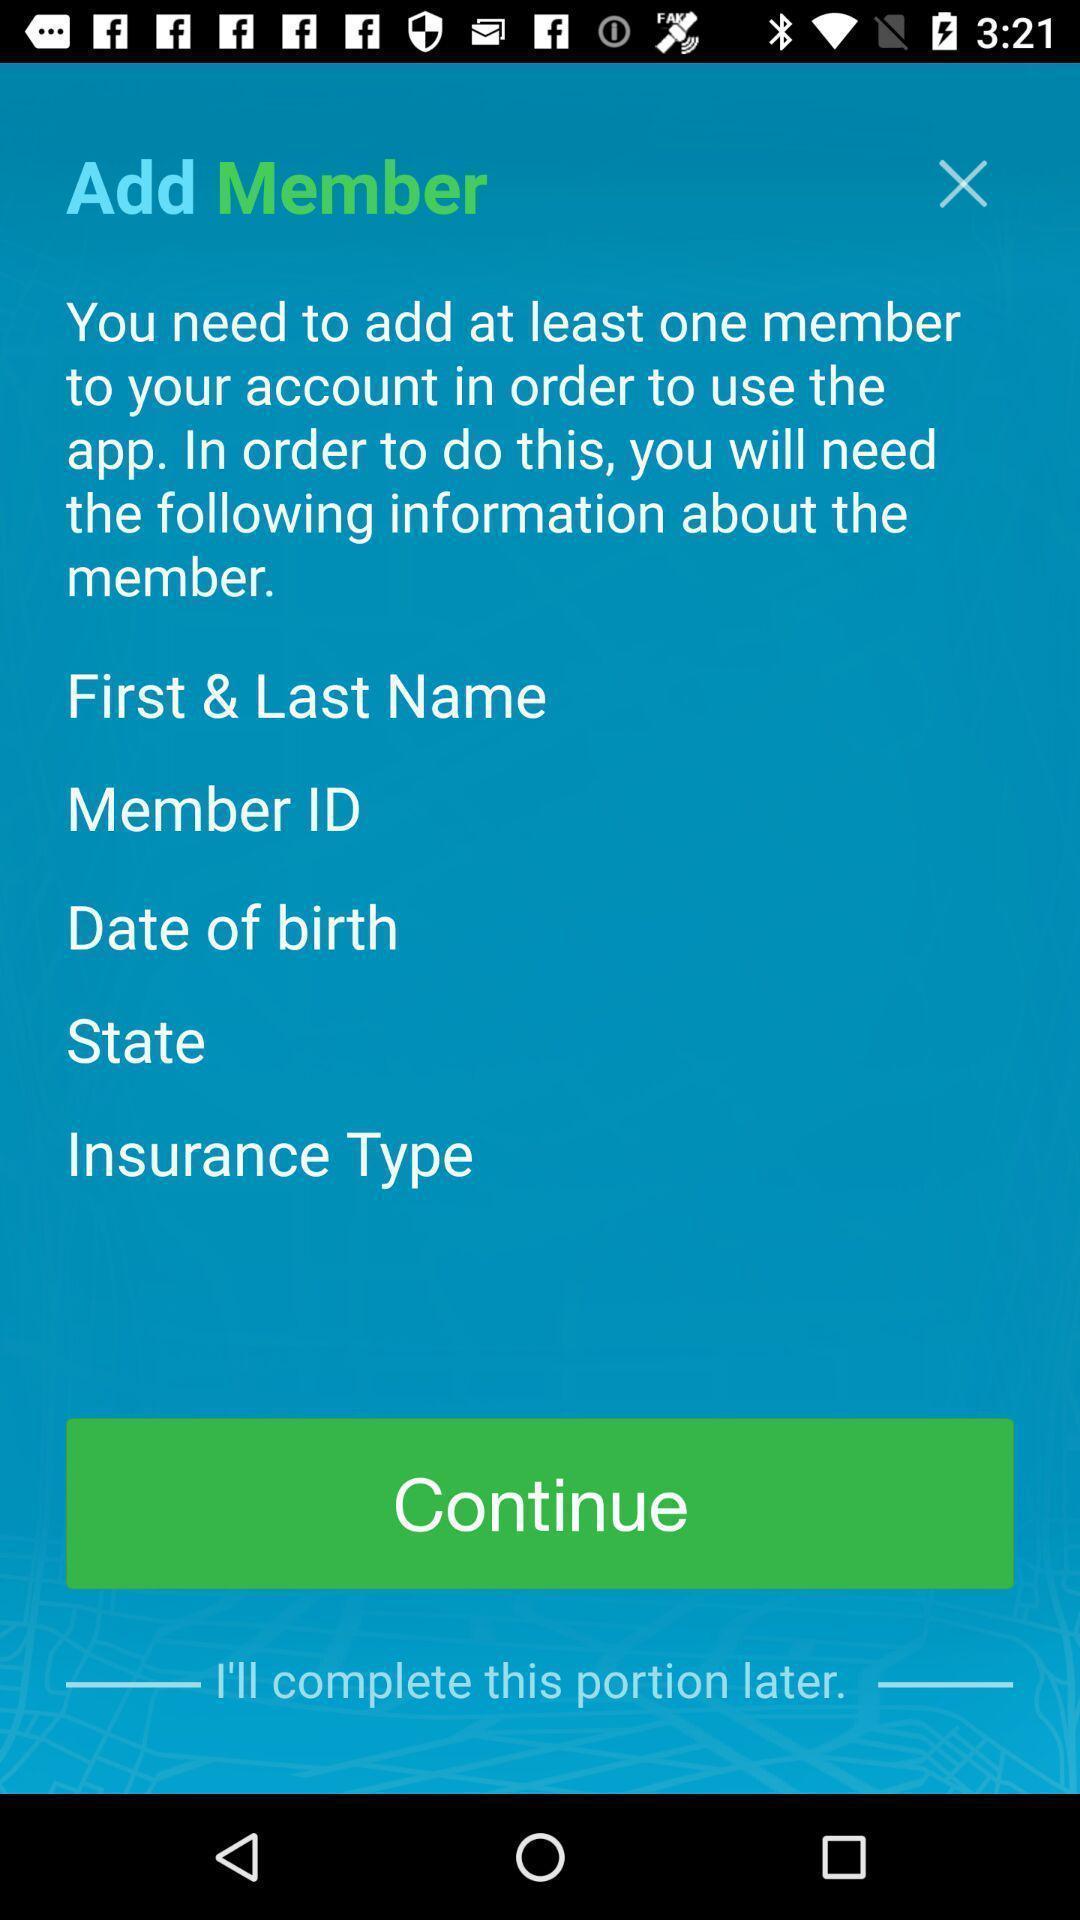Describe this image in words. Page showing add member with continue option. 